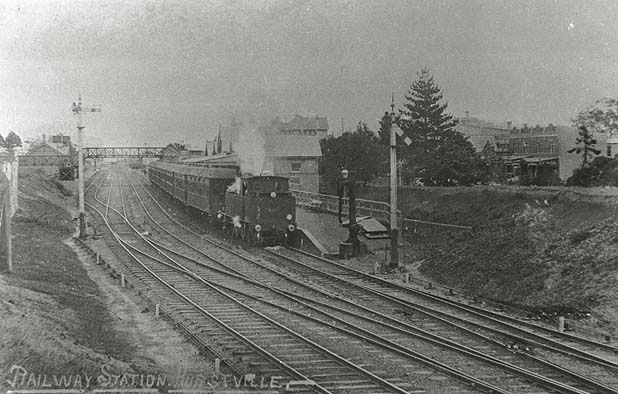Please transcribe the text information in this image. RAILWAY STATION RUSSTVILLE 